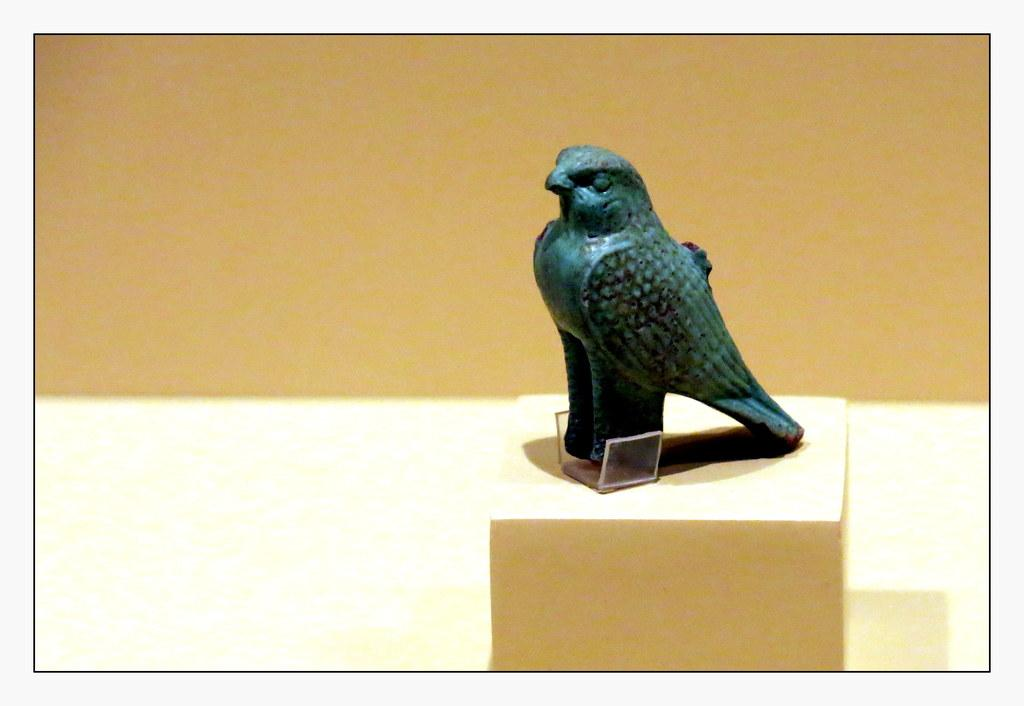What is the main subject of the image? The main subject of the image is a toy parrot. Where is the toy parrot located in the image? The toy parrot is placed on a block. What type of servant is attending to the toy parrot in the image? There is no servant present in the image; it only features a toy parrot placed on a block. 